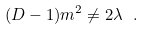Convert formula to latex. <formula><loc_0><loc_0><loc_500><loc_500>( D - 1 ) m ^ { 2 } \neq 2 { \lambda } \ .</formula> 